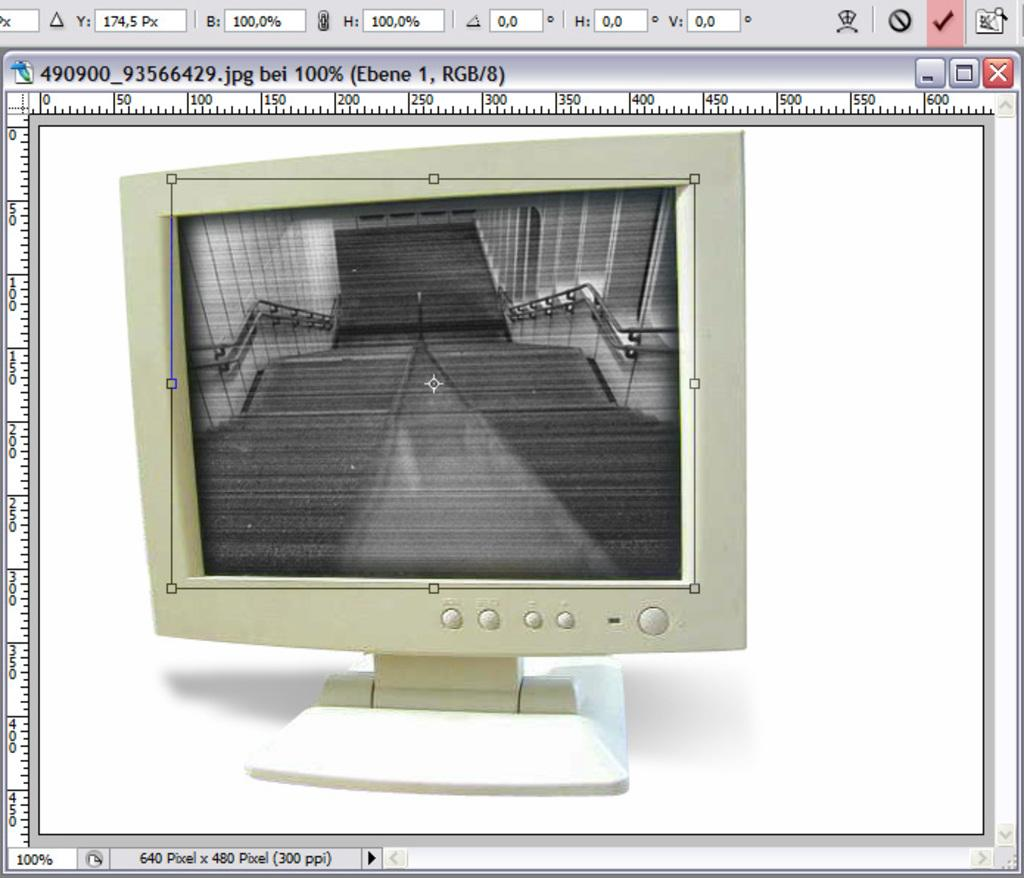<image>
Write a terse but informative summary of the picture. Computer monitor screen that is a jpeg image zoomed at 100% and size of 640 x 480 pixels. 